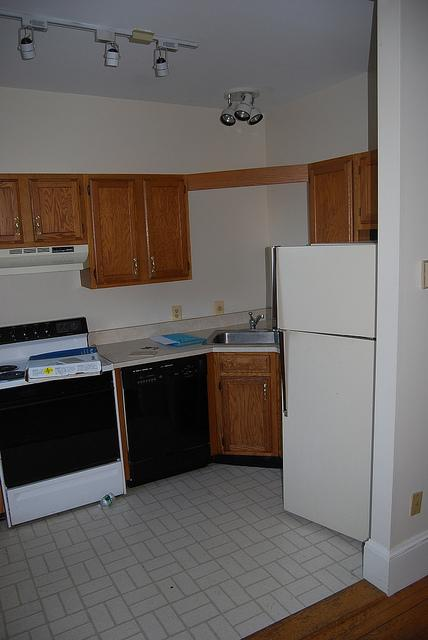What kind of cable is used in the lower right socket?

Choices:
A) diamond
B) severed
C) coax
D) split coax 